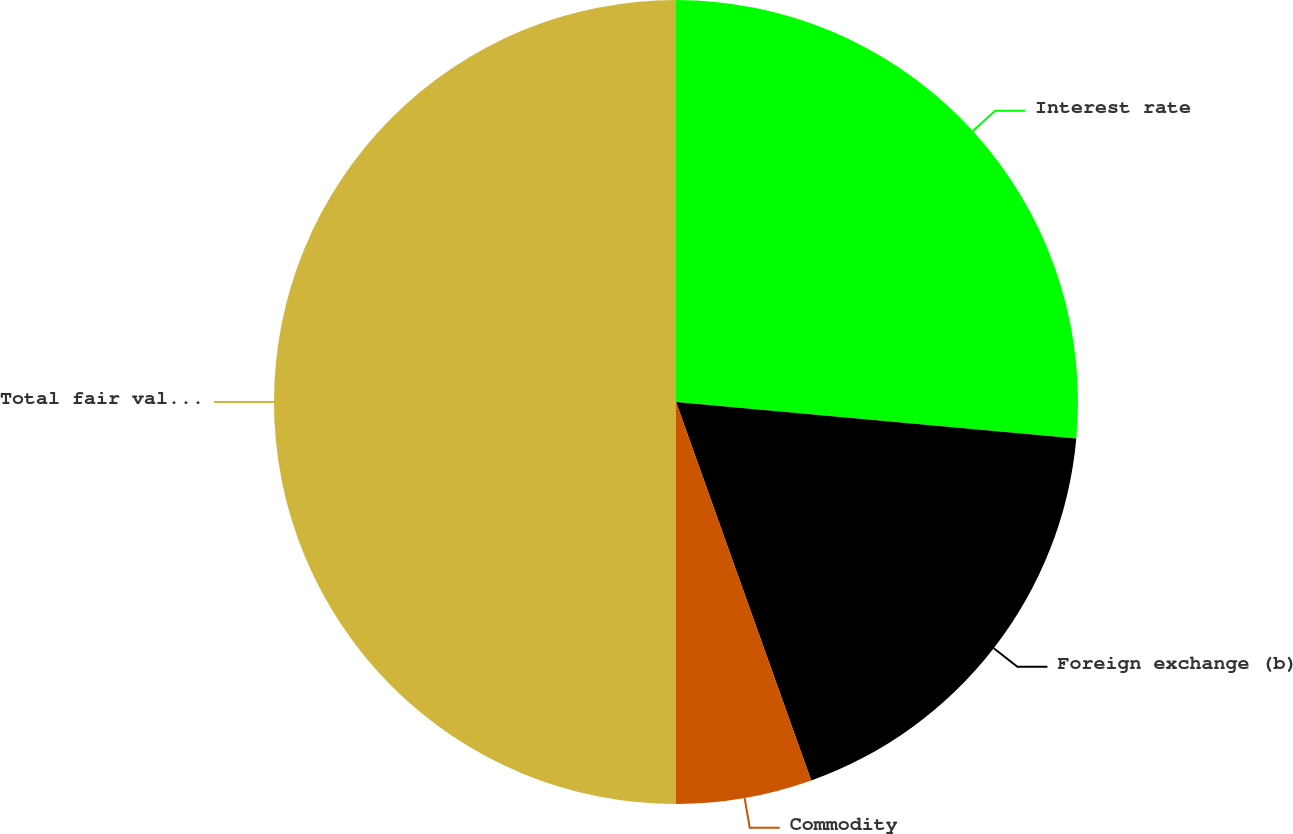<chart> <loc_0><loc_0><loc_500><loc_500><pie_chart><fcel>Interest rate<fcel>Foreign exchange (b)<fcel>Commodity<fcel>Total fair value of trading<nl><fcel>26.45%<fcel>18.09%<fcel>5.46%<fcel>50.0%<nl></chart> 